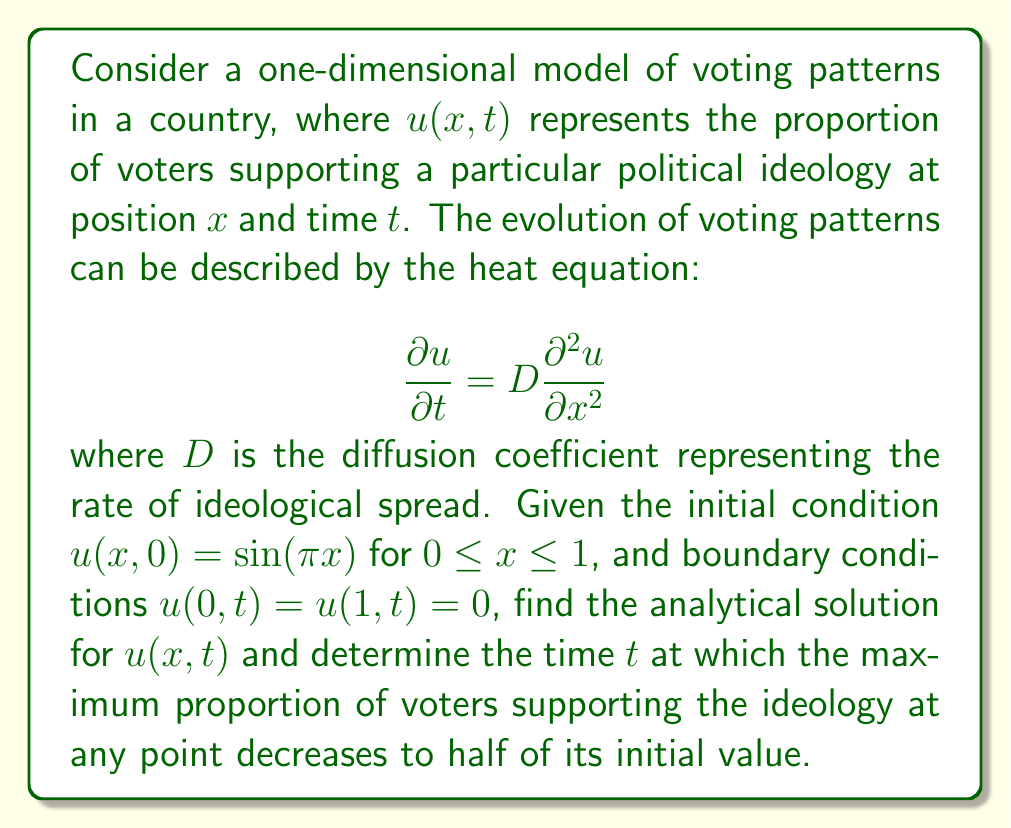Can you answer this question? 1) The general solution to the heat equation with the given boundary conditions is:

   $$u(x,t) = \sum_{n=1}^{\infty} B_n \sin(n\pi x) e^{-Dn^2\pi^2t}$$

2) Given the initial condition $u(x,0) = \sin(\pi x)$, we can see that only the first term of the series is non-zero, with $B_1 = 1$ and $B_n = 0$ for $n > 1$.

3) Therefore, the solution simplifies to:

   $$u(x,t) = \sin(\pi x) e^{-D\pi^2t}$$

4) The maximum proportion occurs at $x = 1/2$ for all $t$. At $t = 0$, this maximum is:

   $$u(1/2,0) = \sin(\pi/2) = 1$$

5) To find when this maximum decreases to half its initial value, we solve:

   $$\sin(\pi/2) e^{-D\pi^2t} = \frac{1}{2}$$

6) Simplifying:

   $$e^{-D\pi^2t} = \frac{1}{2}$$

7) Taking the natural logarithm of both sides:

   $$-D\pi^2t = \ln(\frac{1}{2}) = -\ln(2)$$

8) Solving for $t$:

   $$t = \frac{\ln(2)}{D\pi^2}$$

This is the time at which the maximum proportion of voters supporting the ideology at any point decreases to half of its initial value.
Answer: $t = \frac{\ln(2)}{D\pi^2}$ 